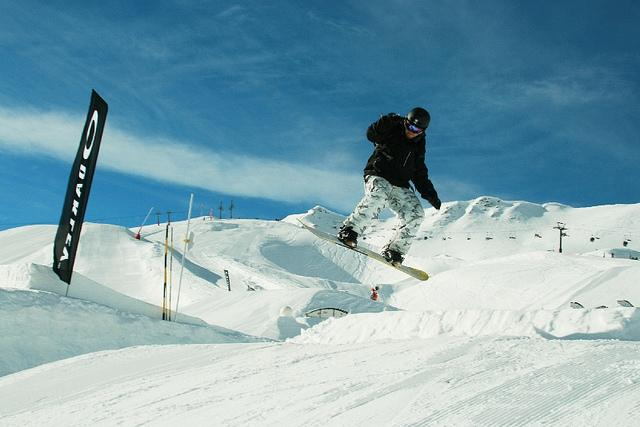Why is the black banner most likely flying in the snowboarder's location? wind 